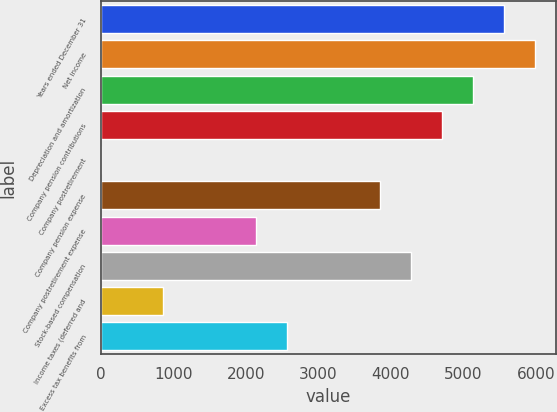Convert chart. <chart><loc_0><loc_0><loc_500><loc_500><bar_chart><fcel>Years ended December 31<fcel>Net income<fcel>Depreciation and amortization<fcel>Company pension contributions<fcel>Company postretirement<fcel>Company pension expense<fcel>Company postretirement expense<fcel>Stock-based compensation<fcel>Income taxes (deferred and<fcel>Excess tax benefits from<nl><fcel>5556.6<fcel>5983.8<fcel>5129.4<fcel>4702.2<fcel>3<fcel>3847.8<fcel>2139<fcel>4275<fcel>857.4<fcel>2566.2<nl></chart> 